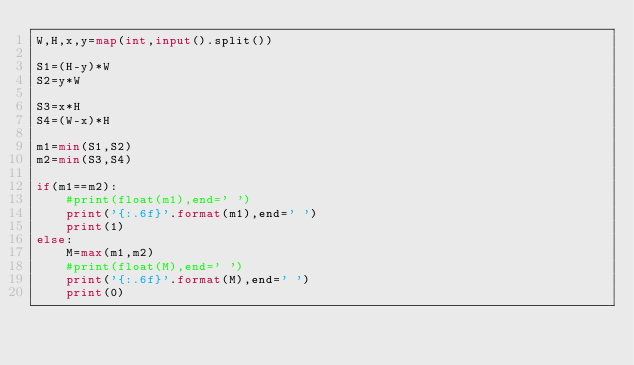Convert code to text. <code><loc_0><loc_0><loc_500><loc_500><_Python_>W,H,x,y=map(int,input().split())

S1=(H-y)*W
S2=y*W

S3=x*H
S4=(W-x)*H

m1=min(S1,S2)
m2=min(S3,S4)

if(m1==m2):
    #print(float(m1),end=' ')
    print('{:.6f}'.format(m1),end=' ')
    print(1)
else:
    M=max(m1,m2)
    #print(float(M),end=' ')
    print('{:.6f}'.format(M),end=' ')
    print(0)
</code> 